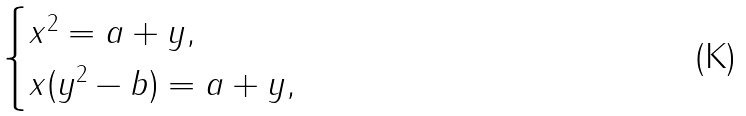<formula> <loc_0><loc_0><loc_500><loc_500>\begin{cases} x ^ { 2 } = a + y , \\ x ( y ^ { 2 } - b ) = a + y , \end{cases}</formula> 